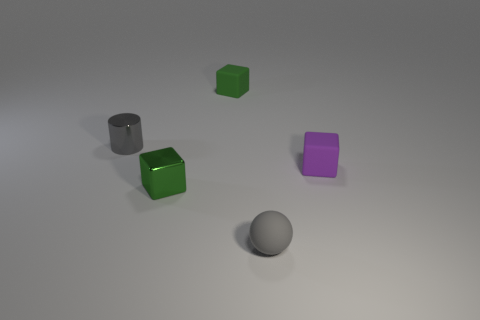The cube that is both right of the small green shiny block and left of the small purple thing is what color?
Offer a terse response. Green. There is a gray thing that is in front of the purple rubber block; what number of rubber things are on the right side of it?
Provide a succinct answer. 1. There is another small green thing that is the same shape as the green metal object; what is it made of?
Ensure brevity in your answer.  Rubber. What is the color of the shiny block?
Provide a short and direct response. Green. How many things are tiny things or small shiny things?
Give a very brief answer. 5. What shape is the gray thing that is to the left of the small gray thing that is on the right side of the green metallic block?
Provide a short and direct response. Cylinder. What number of other objects are the same material as the sphere?
Give a very brief answer. 2. Are the sphere and the tiny cube that is on the right side of the small gray rubber object made of the same material?
Keep it short and to the point. Yes. How many objects are either small rubber blocks in front of the cylinder or cubes right of the tiny green rubber thing?
Ensure brevity in your answer.  1. What number of other things are there of the same color as the small cylinder?
Ensure brevity in your answer.  1. 